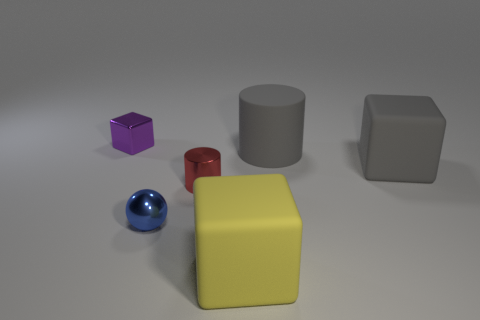Add 3 big gray metal spheres. How many objects exist? 9 Subtract all balls. How many objects are left? 5 Add 3 tiny red metal cylinders. How many tiny red metal cylinders exist? 4 Subtract 1 red cylinders. How many objects are left? 5 Subtract all metallic blocks. Subtract all cubes. How many objects are left? 2 Add 3 big blocks. How many big blocks are left? 5 